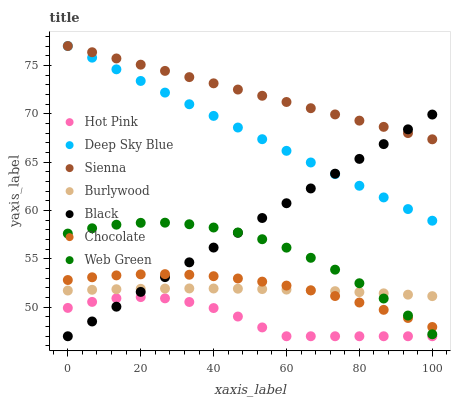Does Hot Pink have the minimum area under the curve?
Answer yes or no. Yes. Does Sienna have the maximum area under the curve?
Answer yes or no. Yes. Does Web Green have the minimum area under the curve?
Answer yes or no. No. Does Web Green have the maximum area under the curve?
Answer yes or no. No. Is Deep Sky Blue the smoothest?
Answer yes or no. Yes. Is Hot Pink the roughest?
Answer yes or no. Yes. Is Web Green the smoothest?
Answer yes or no. No. Is Web Green the roughest?
Answer yes or no. No. Does Hot Pink have the lowest value?
Answer yes or no. Yes. Does Web Green have the lowest value?
Answer yes or no. No. Does Deep Sky Blue have the highest value?
Answer yes or no. Yes. Does Web Green have the highest value?
Answer yes or no. No. Is Web Green less than Deep Sky Blue?
Answer yes or no. Yes. Is Burlywood greater than Hot Pink?
Answer yes or no. Yes. Does Deep Sky Blue intersect Black?
Answer yes or no. Yes. Is Deep Sky Blue less than Black?
Answer yes or no. No. Is Deep Sky Blue greater than Black?
Answer yes or no. No. Does Web Green intersect Deep Sky Blue?
Answer yes or no. No. 